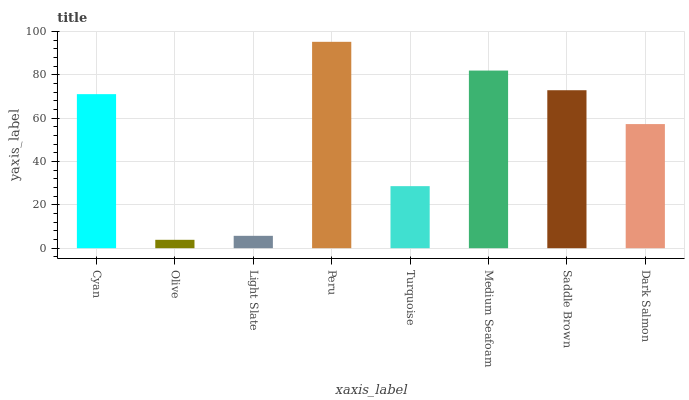Is Light Slate the minimum?
Answer yes or no. No. Is Light Slate the maximum?
Answer yes or no. No. Is Light Slate greater than Olive?
Answer yes or no. Yes. Is Olive less than Light Slate?
Answer yes or no. Yes. Is Olive greater than Light Slate?
Answer yes or no. No. Is Light Slate less than Olive?
Answer yes or no. No. Is Cyan the high median?
Answer yes or no. Yes. Is Dark Salmon the low median?
Answer yes or no. Yes. Is Medium Seafoam the high median?
Answer yes or no. No. Is Olive the low median?
Answer yes or no. No. 